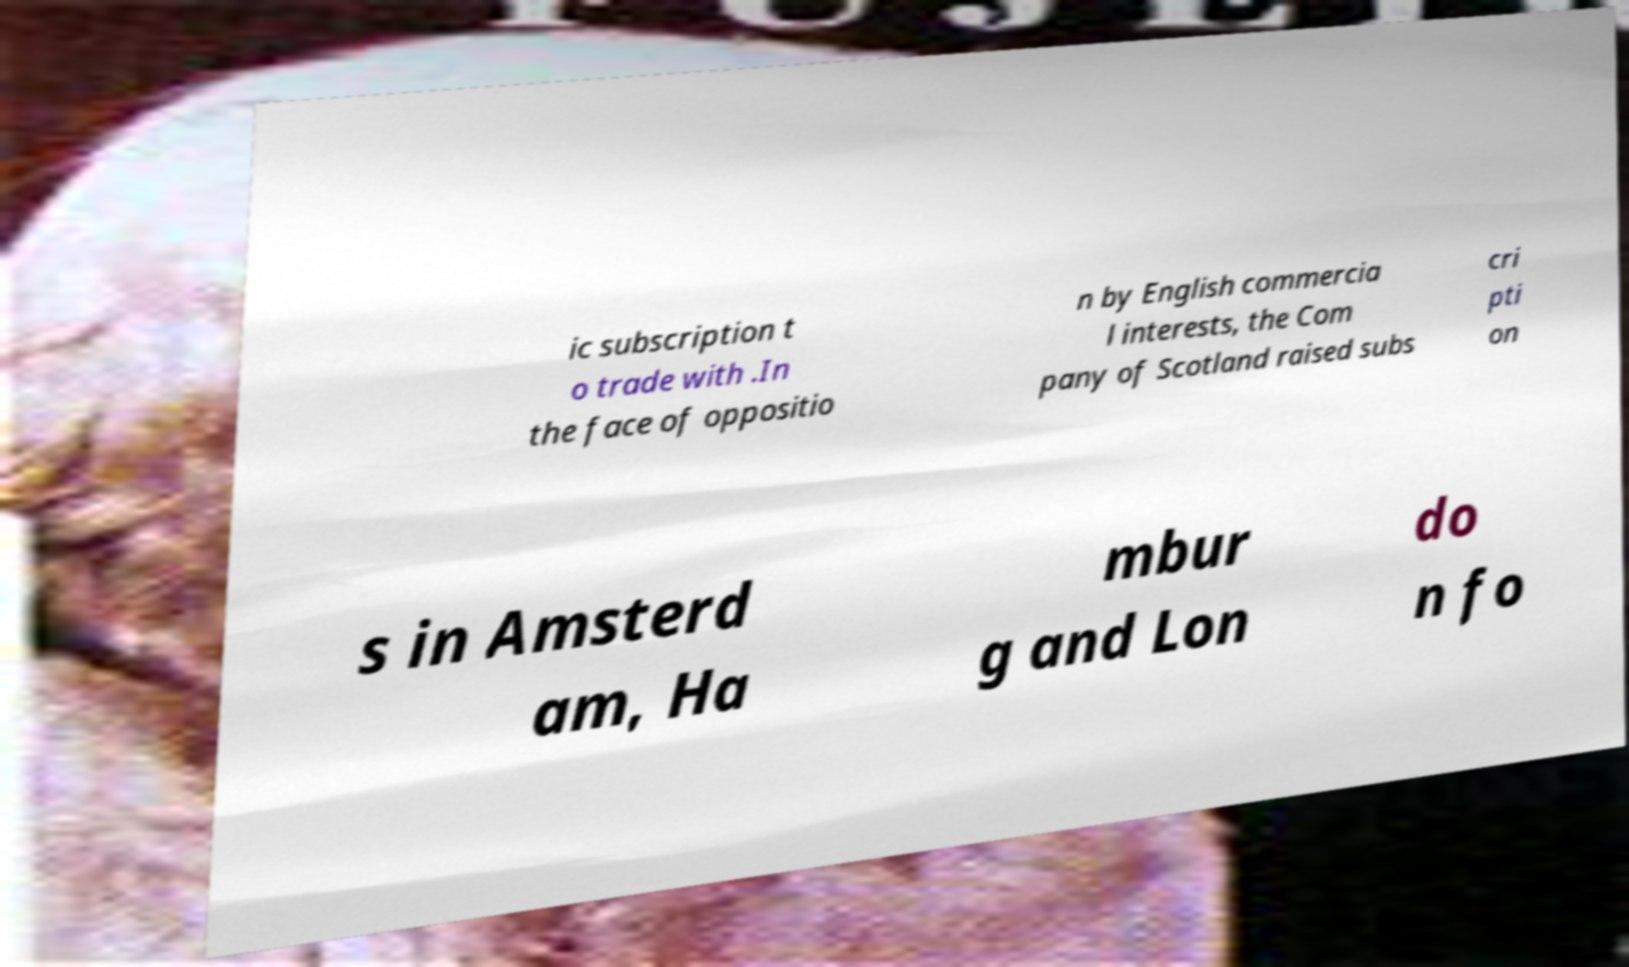Could you assist in decoding the text presented in this image and type it out clearly? ic subscription t o trade with .In the face of oppositio n by English commercia l interests, the Com pany of Scotland raised subs cri pti on s in Amsterd am, Ha mbur g and Lon do n fo 